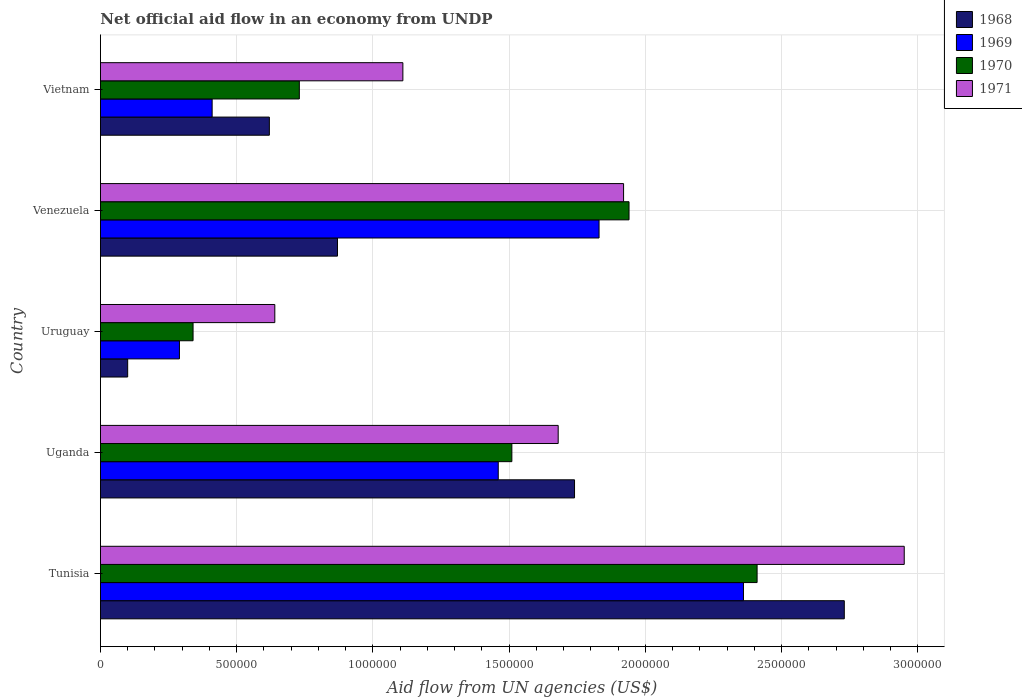What is the label of the 2nd group of bars from the top?
Give a very brief answer. Venezuela. What is the net official aid flow in 1969 in Venezuela?
Offer a terse response. 1.83e+06. Across all countries, what is the maximum net official aid flow in 1970?
Your response must be concise. 2.41e+06. Across all countries, what is the minimum net official aid flow in 1971?
Provide a short and direct response. 6.40e+05. In which country was the net official aid flow in 1971 maximum?
Ensure brevity in your answer.  Tunisia. In which country was the net official aid flow in 1969 minimum?
Give a very brief answer. Uruguay. What is the total net official aid flow in 1968 in the graph?
Your answer should be compact. 6.06e+06. What is the difference between the net official aid flow in 1970 in Uruguay and that in Venezuela?
Your answer should be very brief. -1.60e+06. What is the difference between the net official aid flow in 1970 in Venezuela and the net official aid flow in 1969 in Uruguay?
Ensure brevity in your answer.  1.65e+06. What is the average net official aid flow in 1968 per country?
Give a very brief answer. 1.21e+06. In how many countries, is the net official aid flow in 1969 greater than 2800000 US$?
Your response must be concise. 0. What is the ratio of the net official aid flow in 1969 in Tunisia to that in Uganda?
Provide a short and direct response. 1.62. What is the difference between the highest and the second highest net official aid flow in 1971?
Provide a short and direct response. 1.03e+06. What is the difference between the highest and the lowest net official aid flow in 1969?
Keep it short and to the point. 2.07e+06. What does the 1st bar from the top in Venezuela represents?
Provide a succinct answer. 1971. What does the 1st bar from the bottom in Tunisia represents?
Give a very brief answer. 1968. Is it the case that in every country, the sum of the net official aid flow in 1971 and net official aid flow in 1969 is greater than the net official aid flow in 1968?
Your response must be concise. Yes. How many bars are there?
Your answer should be compact. 20. Are all the bars in the graph horizontal?
Your response must be concise. Yes. How many countries are there in the graph?
Provide a succinct answer. 5. Does the graph contain any zero values?
Give a very brief answer. No. Does the graph contain grids?
Make the answer very short. Yes. How are the legend labels stacked?
Offer a very short reply. Vertical. What is the title of the graph?
Your response must be concise. Net official aid flow in an economy from UNDP. Does "2007" appear as one of the legend labels in the graph?
Provide a short and direct response. No. What is the label or title of the X-axis?
Your answer should be compact. Aid flow from UN agencies (US$). What is the label or title of the Y-axis?
Provide a short and direct response. Country. What is the Aid flow from UN agencies (US$) in 1968 in Tunisia?
Provide a succinct answer. 2.73e+06. What is the Aid flow from UN agencies (US$) in 1969 in Tunisia?
Your response must be concise. 2.36e+06. What is the Aid flow from UN agencies (US$) of 1970 in Tunisia?
Your answer should be compact. 2.41e+06. What is the Aid flow from UN agencies (US$) of 1971 in Tunisia?
Offer a very short reply. 2.95e+06. What is the Aid flow from UN agencies (US$) of 1968 in Uganda?
Ensure brevity in your answer.  1.74e+06. What is the Aid flow from UN agencies (US$) of 1969 in Uganda?
Offer a terse response. 1.46e+06. What is the Aid flow from UN agencies (US$) of 1970 in Uganda?
Offer a terse response. 1.51e+06. What is the Aid flow from UN agencies (US$) in 1971 in Uganda?
Provide a short and direct response. 1.68e+06. What is the Aid flow from UN agencies (US$) in 1968 in Uruguay?
Your response must be concise. 1.00e+05. What is the Aid flow from UN agencies (US$) in 1971 in Uruguay?
Offer a terse response. 6.40e+05. What is the Aid flow from UN agencies (US$) in 1968 in Venezuela?
Offer a very short reply. 8.70e+05. What is the Aid flow from UN agencies (US$) of 1969 in Venezuela?
Offer a terse response. 1.83e+06. What is the Aid flow from UN agencies (US$) in 1970 in Venezuela?
Provide a succinct answer. 1.94e+06. What is the Aid flow from UN agencies (US$) of 1971 in Venezuela?
Your response must be concise. 1.92e+06. What is the Aid flow from UN agencies (US$) in 1968 in Vietnam?
Provide a short and direct response. 6.20e+05. What is the Aid flow from UN agencies (US$) of 1970 in Vietnam?
Your answer should be compact. 7.30e+05. What is the Aid flow from UN agencies (US$) in 1971 in Vietnam?
Provide a short and direct response. 1.11e+06. Across all countries, what is the maximum Aid flow from UN agencies (US$) in 1968?
Your answer should be very brief. 2.73e+06. Across all countries, what is the maximum Aid flow from UN agencies (US$) in 1969?
Your response must be concise. 2.36e+06. Across all countries, what is the maximum Aid flow from UN agencies (US$) in 1970?
Your answer should be very brief. 2.41e+06. Across all countries, what is the maximum Aid flow from UN agencies (US$) of 1971?
Provide a succinct answer. 2.95e+06. Across all countries, what is the minimum Aid flow from UN agencies (US$) of 1968?
Provide a succinct answer. 1.00e+05. Across all countries, what is the minimum Aid flow from UN agencies (US$) of 1970?
Offer a very short reply. 3.40e+05. Across all countries, what is the minimum Aid flow from UN agencies (US$) in 1971?
Give a very brief answer. 6.40e+05. What is the total Aid flow from UN agencies (US$) of 1968 in the graph?
Your response must be concise. 6.06e+06. What is the total Aid flow from UN agencies (US$) of 1969 in the graph?
Keep it short and to the point. 6.35e+06. What is the total Aid flow from UN agencies (US$) in 1970 in the graph?
Offer a terse response. 6.93e+06. What is the total Aid flow from UN agencies (US$) in 1971 in the graph?
Offer a very short reply. 8.30e+06. What is the difference between the Aid flow from UN agencies (US$) in 1968 in Tunisia and that in Uganda?
Make the answer very short. 9.90e+05. What is the difference between the Aid flow from UN agencies (US$) of 1969 in Tunisia and that in Uganda?
Make the answer very short. 9.00e+05. What is the difference between the Aid flow from UN agencies (US$) in 1970 in Tunisia and that in Uganda?
Give a very brief answer. 9.00e+05. What is the difference between the Aid flow from UN agencies (US$) in 1971 in Tunisia and that in Uganda?
Offer a terse response. 1.27e+06. What is the difference between the Aid flow from UN agencies (US$) of 1968 in Tunisia and that in Uruguay?
Your answer should be very brief. 2.63e+06. What is the difference between the Aid flow from UN agencies (US$) of 1969 in Tunisia and that in Uruguay?
Offer a very short reply. 2.07e+06. What is the difference between the Aid flow from UN agencies (US$) of 1970 in Tunisia and that in Uruguay?
Keep it short and to the point. 2.07e+06. What is the difference between the Aid flow from UN agencies (US$) in 1971 in Tunisia and that in Uruguay?
Offer a very short reply. 2.31e+06. What is the difference between the Aid flow from UN agencies (US$) in 1968 in Tunisia and that in Venezuela?
Your answer should be very brief. 1.86e+06. What is the difference between the Aid flow from UN agencies (US$) in 1969 in Tunisia and that in Venezuela?
Provide a succinct answer. 5.30e+05. What is the difference between the Aid flow from UN agencies (US$) of 1970 in Tunisia and that in Venezuela?
Ensure brevity in your answer.  4.70e+05. What is the difference between the Aid flow from UN agencies (US$) in 1971 in Tunisia and that in Venezuela?
Offer a terse response. 1.03e+06. What is the difference between the Aid flow from UN agencies (US$) of 1968 in Tunisia and that in Vietnam?
Give a very brief answer. 2.11e+06. What is the difference between the Aid flow from UN agencies (US$) in 1969 in Tunisia and that in Vietnam?
Your response must be concise. 1.95e+06. What is the difference between the Aid flow from UN agencies (US$) in 1970 in Tunisia and that in Vietnam?
Your answer should be compact. 1.68e+06. What is the difference between the Aid flow from UN agencies (US$) of 1971 in Tunisia and that in Vietnam?
Offer a very short reply. 1.84e+06. What is the difference between the Aid flow from UN agencies (US$) of 1968 in Uganda and that in Uruguay?
Your response must be concise. 1.64e+06. What is the difference between the Aid flow from UN agencies (US$) in 1969 in Uganda and that in Uruguay?
Your answer should be compact. 1.17e+06. What is the difference between the Aid flow from UN agencies (US$) in 1970 in Uganda and that in Uruguay?
Make the answer very short. 1.17e+06. What is the difference between the Aid flow from UN agencies (US$) of 1971 in Uganda and that in Uruguay?
Your answer should be compact. 1.04e+06. What is the difference between the Aid flow from UN agencies (US$) in 1968 in Uganda and that in Venezuela?
Your answer should be compact. 8.70e+05. What is the difference between the Aid flow from UN agencies (US$) in 1969 in Uganda and that in Venezuela?
Make the answer very short. -3.70e+05. What is the difference between the Aid flow from UN agencies (US$) in 1970 in Uganda and that in Venezuela?
Your response must be concise. -4.30e+05. What is the difference between the Aid flow from UN agencies (US$) in 1971 in Uganda and that in Venezuela?
Your response must be concise. -2.40e+05. What is the difference between the Aid flow from UN agencies (US$) of 1968 in Uganda and that in Vietnam?
Your answer should be very brief. 1.12e+06. What is the difference between the Aid flow from UN agencies (US$) in 1969 in Uganda and that in Vietnam?
Provide a short and direct response. 1.05e+06. What is the difference between the Aid flow from UN agencies (US$) in 1970 in Uganda and that in Vietnam?
Your answer should be very brief. 7.80e+05. What is the difference between the Aid flow from UN agencies (US$) in 1971 in Uganda and that in Vietnam?
Provide a short and direct response. 5.70e+05. What is the difference between the Aid flow from UN agencies (US$) of 1968 in Uruguay and that in Venezuela?
Provide a succinct answer. -7.70e+05. What is the difference between the Aid flow from UN agencies (US$) in 1969 in Uruguay and that in Venezuela?
Provide a short and direct response. -1.54e+06. What is the difference between the Aid flow from UN agencies (US$) of 1970 in Uruguay and that in Venezuela?
Offer a terse response. -1.60e+06. What is the difference between the Aid flow from UN agencies (US$) of 1971 in Uruguay and that in Venezuela?
Offer a very short reply. -1.28e+06. What is the difference between the Aid flow from UN agencies (US$) of 1968 in Uruguay and that in Vietnam?
Make the answer very short. -5.20e+05. What is the difference between the Aid flow from UN agencies (US$) of 1970 in Uruguay and that in Vietnam?
Make the answer very short. -3.90e+05. What is the difference between the Aid flow from UN agencies (US$) of 1971 in Uruguay and that in Vietnam?
Offer a very short reply. -4.70e+05. What is the difference between the Aid flow from UN agencies (US$) of 1969 in Venezuela and that in Vietnam?
Give a very brief answer. 1.42e+06. What is the difference between the Aid flow from UN agencies (US$) of 1970 in Venezuela and that in Vietnam?
Keep it short and to the point. 1.21e+06. What is the difference between the Aid flow from UN agencies (US$) of 1971 in Venezuela and that in Vietnam?
Your answer should be compact. 8.10e+05. What is the difference between the Aid flow from UN agencies (US$) in 1968 in Tunisia and the Aid flow from UN agencies (US$) in 1969 in Uganda?
Your answer should be compact. 1.27e+06. What is the difference between the Aid flow from UN agencies (US$) of 1968 in Tunisia and the Aid flow from UN agencies (US$) of 1970 in Uganda?
Give a very brief answer. 1.22e+06. What is the difference between the Aid flow from UN agencies (US$) in 1968 in Tunisia and the Aid flow from UN agencies (US$) in 1971 in Uganda?
Your answer should be very brief. 1.05e+06. What is the difference between the Aid flow from UN agencies (US$) of 1969 in Tunisia and the Aid flow from UN agencies (US$) of 1970 in Uganda?
Ensure brevity in your answer.  8.50e+05. What is the difference between the Aid flow from UN agencies (US$) of 1969 in Tunisia and the Aid flow from UN agencies (US$) of 1971 in Uganda?
Ensure brevity in your answer.  6.80e+05. What is the difference between the Aid flow from UN agencies (US$) in 1970 in Tunisia and the Aid flow from UN agencies (US$) in 1971 in Uganda?
Provide a succinct answer. 7.30e+05. What is the difference between the Aid flow from UN agencies (US$) in 1968 in Tunisia and the Aid flow from UN agencies (US$) in 1969 in Uruguay?
Keep it short and to the point. 2.44e+06. What is the difference between the Aid flow from UN agencies (US$) of 1968 in Tunisia and the Aid flow from UN agencies (US$) of 1970 in Uruguay?
Offer a terse response. 2.39e+06. What is the difference between the Aid flow from UN agencies (US$) in 1968 in Tunisia and the Aid flow from UN agencies (US$) in 1971 in Uruguay?
Offer a terse response. 2.09e+06. What is the difference between the Aid flow from UN agencies (US$) in 1969 in Tunisia and the Aid flow from UN agencies (US$) in 1970 in Uruguay?
Offer a very short reply. 2.02e+06. What is the difference between the Aid flow from UN agencies (US$) of 1969 in Tunisia and the Aid flow from UN agencies (US$) of 1971 in Uruguay?
Give a very brief answer. 1.72e+06. What is the difference between the Aid flow from UN agencies (US$) of 1970 in Tunisia and the Aid flow from UN agencies (US$) of 1971 in Uruguay?
Ensure brevity in your answer.  1.77e+06. What is the difference between the Aid flow from UN agencies (US$) in 1968 in Tunisia and the Aid flow from UN agencies (US$) in 1970 in Venezuela?
Your response must be concise. 7.90e+05. What is the difference between the Aid flow from UN agencies (US$) of 1968 in Tunisia and the Aid flow from UN agencies (US$) of 1971 in Venezuela?
Offer a terse response. 8.10e+05. What is the difference between the Aid flow from UN agencies (US$) of 1969 in Tunisia and the Aid flow from UN agencies (US$) of 1970 in Venezuela?
Provide a short and direct response. 4.20e+05. What is the difference between the Aid flow from UN agencies (US$) of 1969 in Tunisia and the Aid flow from UN agencies (US$) of 1971 in Venezuela?
Keep it short and to the point. 4.40e+05. What is the difference between the Aid flow from UN agencies (US$) of 1970 in Tunisia and the Aid flow from UN agencies (US$) of 1971 in Venezuela?
Offer a terse response. 4.90e+05. What is the difference between the Aid flow from UN agencies (US$) of 1968 in Tunisia and the Aid flow from UN agencies (US$) of 1969 in Vietnam?
Ensure brevity in your answer.  2.32e+06. What is the difference between the Aid flow from UN agencies (US$) in 1968 in Tunisia and the Aid flow from UN agencies (US$) in 1971 in Vietnam?
Your answer should be compact. 1.62e+06. What is the difference between the Aid flow from UN agencies (US$) in 1969 in Tunisia and the Aid flow from UN agencies (US$) in 1970 in Vietnam?
Your answer should be very brief. 1.63e+06. What is the difference between the Aid flow from UN agencies (US$) in 1969 in Tunisia and the Aid flow from UN agencies (US$) in 1971 in Vietnam?
Keep it short and to the point. 1.25e+06. What is the difference between the Aid flow from UN agencies (US$) of 1970 in Tunisia and the Aid flow from UN agencies (US$) of 1971 in Vietnam?
Provide a succinct answer. 1.30e+06. What is the difference between the Aid flow from UN agencies (US$) of 1968 in Uganda and the Aid flow from UN agencies (US$) of 1969 in Uruguay?
Your response must be concise. 1.45e+06. What is the difference between the Aid flow from UN agencies (US$) of 1968 in Uganda and the Aid flow from UN agencies (US$) of 1970 in Uruguay?
Keep it short and to the point. 1.40e+06. What is the difference between the Aid flow from UN agencies (US$) in 1968 in Uganda and the Aid flow from UN agencies (US$) in 1971 in Uruguay?
Offer a terse response. 1.10e+06. What is the difference between the Aid flow from UN agencies (US$) in 1969 in Uganda and the Aid flow from UN agencies (US$) in 1970 in Uruguay?
Your answer should be compact. 1.12e+06. What is the difference between the Aid flow from UN agencies (US$) in 1969 in Uganda and the Aid flow from UN agencies (US$) in 1971 in Uruguay?
Offer a terse response. 8.20e+05. What is the difference between the Aid flow from UN agencies (US$) of 1970 in Uganda and the Aid flow from UN agencies (US$) of 1971 in Uruguay?
Give a very brief answer. 8.70e+05. What is the difference between the Aid flow from UN agencies (US$) in 1969 in Uganda and the Aid flow from UN agencies (US$) in 1970 in Venezuela?
Give a very brief answer. -4.80e+05. What is the difference between the Aid flow from UN agencies (US$) in 1969 in Uganda and the Aid flow from UN agencies (US$) in 1971 in Venezuela?
Make the answer very short. -4.60e+05. What is the difference between the Aid flow from UN agencies (US$) of 1970 in Uganda and the Aid flow from UN agencies (US$) of 1971 in Venezuela?
Give a very brief answer. -4.10e+05. What is the difference between the Aid flow from UN agencies (US$) of 1968 in Uganda and the Aid flow from UN agencies (US$) of 1969 in Vietnam?
Provide a short and direct response. 1.33e+06. What is the difference between the Aid flow from UN agencies (US$) in 1968 in Uganda and the Aid flow from UN agencies (US$) in 1970 in Vietnam?
Provide a short and direct response. 1.01e+06. What is the difference between the Aid flow from UN agencies (US$) of 1968 in Uganda and the Aid flow from UN agencies (US$) of 1971 in Vietnam?
Your response must be concise. 6.30e+05. What is the difference between the Aid flow from UN agencies (US$) of 1969 in Uganda and the Aid flow from UN agencies (US$) of 1970 in Vietnam?
Offer a very short reply. 7.30e+05. What is the difference between the Aid flow from UN agencies (US$) of 1970 in Uganda and the Aid flow from UN agencies (US$) of 1971 in Vietnam?
Your answer should be compact. 4.00e+05. What is the difference between the Aid flow from UN agencies (US$) in 1968 in Uruguay and the Aid flow from UN agencies (US$) in 1969 in Venezuela?
Your response must be concise. -1.73e+06. What is the difference between the Aid flow from UN agencies (US$) of 1968 in Uruguay and the Aid flow from UN agencies (US$) of 1970 in Venezuela?
Your answer should be compact. -1.84e+06. What is the difference between the Aid flow from UN agencies (US$) in 1968 in Uruguay and the Aid flow from UN agencies (US$) in 1971 in Venezuela?
Offer a very short reply. -1.82e+06. What is the difference between the Aid flow from UN agencies (US$) in 1969 in Uruguay and the Aid flow from UN agencies (US$) in 1970 in Venezuela?
Your response must be concise. -1.65e+06. What is the difference between the Aid flow from UN agencies (US$) of 1969 in Uruguay and the Aid flow from UN agencies (US$) of 1971 in Venezuela?
Your response must be concise. -1.63e+06. What is the difference between the Aid flow from UN agencies (US$) in 1970 in Uruguay and the Aid flow from UN agencies (US$) in 1971 in Venezuela?
Your answer should be compact. -1.58e+06. What is the difference between the Aid flow from UN agencies (US$) in 1968 in Uruguay and the Aid flow from UN agencies (US$) in 1969 in Vietnam?
Provide a short and direct response. -3.10e+05. What is the difference between the Aid flow from UN agencies (US$) of 1968 in Uruguay and the Aid flow from UN agencies (US$) of 1970 in Vietnam?
Offer a very short reply. -6.30e+05. What is the difference between the Aid flow from UN agencies (US$) of 1968 in Uruguay and the Aid flow from UN agencies (US$) of 1971 in Vietnam?
Ensure brevity in your answer.  -1.01e+06. What is the difference between the Aid flow from UN agencies (US$) in 1969 in Uruguay and the Aid flow from UN agencies (US$) in 1970 in Vietnam?
Your response must be concise. -4.40e+05. What is the difference between the Aid flow from UN agencies (US$) of 1969 in Uruguay and the Aid flow from UN agencies (US$) of 1971 in Vietnam?
Provide a short and direct response. -8.20e+05. What is the difference between the Aid flow from UN agencies (US$) in 1970 in Uruguay and the Aid flow from UN agencies (US$) in 1971 in Vietnam?
Your answer should be compact. -7.70e+05. What is the difference between the Aid flow from UN agencies (US$) of 1968 in Venezuela and the Aid flow from UN agencies (US$) of 1969 in Vietnam?
Ensure brevity in your answer.  4.60e+05. What is the difference between the Aid flow from UN agencies (US$) in 1968 in Venezuela and the Aid flow from UN agencies (US$) in 1970 in Vietnam?
Keep it short and to the point. 1.40e+05. What is the difference between the Aid flow from UN agencies (US$) in 1968 in Venezuela and the Aid flow from UN agencies (US$) in 1971 in Vietnam?
Offer a very short reply. -2.40e+05. What is the difference between the Aid flow from UN agencies (US$) in 1969 in Venezuela and the Aid flow from UN agencies (US$) in 1970 in Vietnam?
Provide a short and direct response. 1.10e+06. What is the difference between the Aid flow from UN agencies (US$) of 1969 in Venezuela and the Aid flow from UN agencies (US$) of 1971 in Vietnam?
Give a very brief answer. 7.20e+05. What is the difference between the Aid flow from UN agencies (US$) of 1970 in Venezuela and the Aid flow from UN agencies (US$) of 1971 in Vietnam?
Give a very brief answer. 8.30e+05. What is the average Aid flow from UN agencies (US$) of 1968 per country?
Make the answer very short. 1.21e+06. What is the average Aid flow from UN agencies (US$) of 1969 per country?
Your response must be concise. 1.27e+06. What is the average Aid flow from UN agencies (US$) in 1970 per country?
Keep it short and to the point. 1.39e+06. What is the average Aid flow from UN agencies (US$) of 1971 per country?
Your answer should be compact. 1.66e+06. What is the difference between the Aid flow from UN agencies (US$) in 1968 and Aid flow from UN agencies (US$) in 1969 in Tunisia?
Make the answer very short. 3.70e+05. What is the difference between the Aid flow from UN agencies (US$) of 1969 and Aid flow from UN agencies (US$) of 1971 in Tunisia?
Your response must be concise. -5.90e+05. What is the difference between the Aid flow from UN agencies (US$) in 1970 and Aid flow from UN agencies (US$) in 1971 in Tunisia?
Your answer should be compact. -5.40e+05. What is the difference between the Aid flow from UN agencies (US$) of 1968 and Aid flow from UN agencies (US$) of 1970 in Uganda?
Your response must be concise. 2.30e+05. What is the difference between the Aid flow from UN agencies (US$) of 1968 and Aid flow from UN agencies (US$) of 1971 in Uganda?
Your response must be concise. 6.00e+04. What is the difference between the Aid flow from UN agencies (US$) of 1969 and Aid flow from UN agencies (US$) of 1970 in Uganda?
Provide a succinct answer. -5.00e+04. What is the difference between the Aid flow from UN agencies (US$) of 1970 and Aid flow from UN agencies (US$) of 1971 in Uganda?
Your answer should be compact. -1.70e+05. What is the difference between the Aid flow from UN agencies (US$) of 1968 and Aid flow from UN agencies (US$) of 1970 in Uruguay?
Keep it short and to the point. -2.40e+05. What is the difference between the Aid flow from UN agencies (US$) in 1968 and Aid flow from UN agencies (US$) in 1971 in Uruguay?
Your answer should be very brief. -5.40e+05. What is the difference between the Aid flow from UN agencies (US$) of 1969 and Aid flow from UN agencies (US$) of 1970 in Uruguay?
Ensure brevity in your answer.  -5.00e+04. What is the difference between the Aid flow from UN agencies (US$) in 1969 and Aid flow from UN agencies (US$) in 1971 in Uruguay?
Your response must be concise. -3.50e+05. What is the difference between the Aid flow from UN agencies (US$) of 1970 and Aid flow from UN agencies (US$) of 1971 in Uruguay?
Provide a short and direct response. -3.00e+05. What is the difference between the Aid flow from UN agencies (US$) of 1968 and Aid flow from UN agencies (US$) of 1969 in Venezuela?
Provide a short and direct response. -9.60e+05. What is the difference between the Aid flow from UN agencies (US$) in 1968 and Aid flow from UN agencies (US$) in 1970 in Venezuela?
Make the answer very short. -1.07e+06. What is the difference between the Aid flow from UN agencies (US$) of 1968 and Aid flow from UN agencies (US$) of 1971 in Venezuela?
Provide a short and direct response. -1.05e+06. What is the difference between the Aid flow from UN agencies (US$) of 1969 and Aid flow from UN agencies (US$) of 1971 in Venezuela?
Your answer should be compact. -9.00e+04. What is the difference between the Aid flow from UN agencies (US$) of 1970 and Aid flow from UN agencies (US$) of 1971 in Venezuela?
Keep it short and to the point. 2.00e+04. What is the difference between the Aid flow from UN agencies (US$) of 1968 and Aid flow from UN agencies (US$) of 1971 in Vietnam?
Provide a succinct answer. -4.90e+05. What is the difference between the Aid flow from UN agencies (US$) of 1969 and Aid flow from UN agencies (US$) of 1970 in Vietnam?
Provide a short and direct response. -3.20e+05. What is the difference between the Aid flow from UN agencies (US$) in 1969 and Aid flow from UN agencies (US$) in 1971 in Vietnam?
Provide a short and direct response. -7.00e+05. What is the difference between the Aid flow from UN agencies (US$) in 1970 and Aid flow from UN agencies (US$) in 1971 in Vietnam?
Ensure brevity in your answer.  -3.80e+05. What is the ratio of the Aid flow from UN agencies (US$) in 1968 in Tunisia to that in Uganda?
Make the answer very short. 1.57. What is the ratio of the Aid flow from UN agencies (US$) of 1969 in Tunisia to that in Uganda?
Offer a terse response. 1.62. What is the ratio of the Aid flow from UN agencies (US$) of 1970 in Tunisia to that in Uganda?
Offer a terse response. 1.6. What is the ratio of the Aid flow from UN agencies (US$) of 1971 in Tunisia to that in Uganda?
Your answer should be compact. 1.76. What is the ratio of the Aid flow from UN agencies (US$) in 1968 in Tunisia to that in Uruguay?
Provide a short and direct response. 27.3. What is the ratio of the Aid flow from UN agencies (US$) in 1969 in Tunisia to that in Uruguay?
Offer a terse response. 8.14. What is the ratio of the Aid flow from UN agencies (US$) in 1970 in Tunisia to that in Uruguay?
Offer a terse response. 7.09. What is the ratio of the Aid flow from UN agencies (US$) in 1971 in Tunisia to that in Uruguay?
Provide a succinct answer. 4.61. What is the ratio of the Aid flow from UN agencies (US$) of 1968 in Tunisia to that in Venezuela?
Keep it short and to the point. 3.14. What is the ratio of the Aid flow from UN agencies (US$) in 1969 in Tunisia to that in Venezuela?
Keep it short and to the point. 1.29. What is the ratio of the Aid flow from UN agencies (US$) of 1970 in Tunisia to that in Venezuela?
Provide a succinct answer. 1.24. What is the ratio of the Aid flow from UN agencies (US$) in 1971 in Tunisia to that in Venezuela?
Provide a short and direct response. 1.54. What is the ratio of the Aid flow from UN agencies (US$) in 1968 in Tunisia to that in Vietnam?
Your answer should be compact. 4.4. What is the ratio of the Aid flow from UN agencies (US$) of 1969 in Tunisia to that in Vietnam?
Provide a succinct answer. 5.76. What is the ratio of the Aid flow from UN agencies (US$) in 1970 in Tunisia to that in Vietnam?
Offer a very short reply. 3.3. What is the ratio of the Aid flow from UN agencies (US$) in 1971 in Tunisia to that in Vietnam?
Provide a succinct answer. 2.66. What is the ratio of the Aid flow from UN agencies (US$) in 1968 in Uganda to that in Uruguay?
Offer a very short reply. 17.4. What is the ratio of the Aid flow from UN agencies (US$) of 1969 in Uganda to that in Uruguay?
Keep it short and to the point. 5.03. What is the ratio of the Aid flow from UN agencies (US$) in 1970 in Uganda to that in Uruguay?
Your response must be concise. 4.44. What is the ratio of the Aid flow from UN agencies (US$) of 1971 in Uganda to that in Uruguay?
Make the answer very short. 2.62. What is the ratio of the Aid flow from UN agencies (US$) of 1969 in Uganda to that in Venezuela?
Ensure brevity in your answer.  0.8. What is the ratio of the Aid flow from UN agencies (US$) in 1970 in Uganda to that in Venezuela?
Offer a very short reply. 0.78. What is the ratio of the Aid flow from UN agencies (US$) in 1968 in Uganda to that in Vietnam?
Your answer should be very brief. 2.81. What is the ratio of the Aid flow from UN agencies (US$) of 1969 in Uganda to that in Vietnam?
Give a very brief answer. 3.56. What is the ratio of the Aid flow from UN agencies (US$) in 1970 in Uganda to that in Vietnam?
Make the answer very short. 2.07. What is the ratio of the Aid flow from UN agencies (US$) of 1971 in Uganda to that in Vietnam?
Provide a short and direct response. 1.51. What is the ratio of the Aid flow from UN agencies (US$) of 1968 in Uruguay to that in Venezuela?
Provide a short and direct response. 0.11. What is the ratio of the Aid flow from UN agencies (US$) in 1969 in Uruguay to that in Venezuela?
Provide a short and direct response. 0.16. What is the ratio of the Aid flow from UN agencies (US$) of 1970 in Uruguay to that in Venezuela?
Ensure brevity in your answer.  0.18. What is the ratio of the Aid flow from UN agencies (US$) of 1971 in Uruguay to that in Venezuela?
Make the answer very short. 0.33. What is the ratio of the Aid flow from UN agencies (US$) of 1968 in Uruguay to that in Vietnam?
Give a very brief answer. 0.16. What is the ratio of the Aid flow from UN agencies (US$) of 1969 in Uruguay to that in Vietnam?
Make the answer very short. 0.71. What is the ratio of the Aid flow from UN agencies (US$) in 1970 in Uruguay to that in Vietnam?
Offer a very short reply. 0.47. What is the ratio of the Aid flow from UN agencies (US$) of 1971 in Uruguay to that in Vietnam?
Provide a short and direct response. 0.58. What is the ratio of the Aid flow from UN agencies (US$) in 1968 in Venezuela to that in Vietnam?
Your answer should be compact. 1.4. What is the ratio of the Aid flow from UN agencies (US$) of 1969 in Venezuela to that in Vietnam?
Your answer should be very brief. 4.46. What is the ratio of the Aid flow from UN agencies (US$) of 1970 in Venezuela to that in Vietnam?
Give a very brief answer. 2.66. What is the ratio of the Aid flow from UN agencies (US$) of 1971 in Venezuela to that in Vietnam?
Ensure brevity in your answer.  1.73. What is the difference between the highest and the second highest Aid flow from UN agencies (US$) in 1968?
Your answer should be very brief. 9.90e+05. What is the difference between the highest and the second highest Aid flow from UN agencies (US$) of 1969?
Provide a short and direct response. 5.30e+05. What is the difference between the highest and the second highest Aid flow from UN agencies (US$) of 1970?
Provide a succinct answer. 4.70e+05. What is the difference between the highest and the second highest Aid flow from UN agencies (US$) in 1971?
Keep it short and to the point. 1.03e+06. What is the difference between the highest and the lowest Aid flow from UN agencies (US$) in 1968?
Your answer should be compact. 2.63e+06. What is the difference between the highest and the lowest Aid flow from UN agencies (US$) of 1969?
Give a very brief answer. 2.07e+06. What is the difference between the highest and the lowest Aid flow from UN agencies (US$) of 1970?
Make the answer very short. 2.07e+06. What is the difference between the highest and the lowest Aid flow from UN agencies (US$) in 1971?
Your response must be concise. 2.31e+06. 